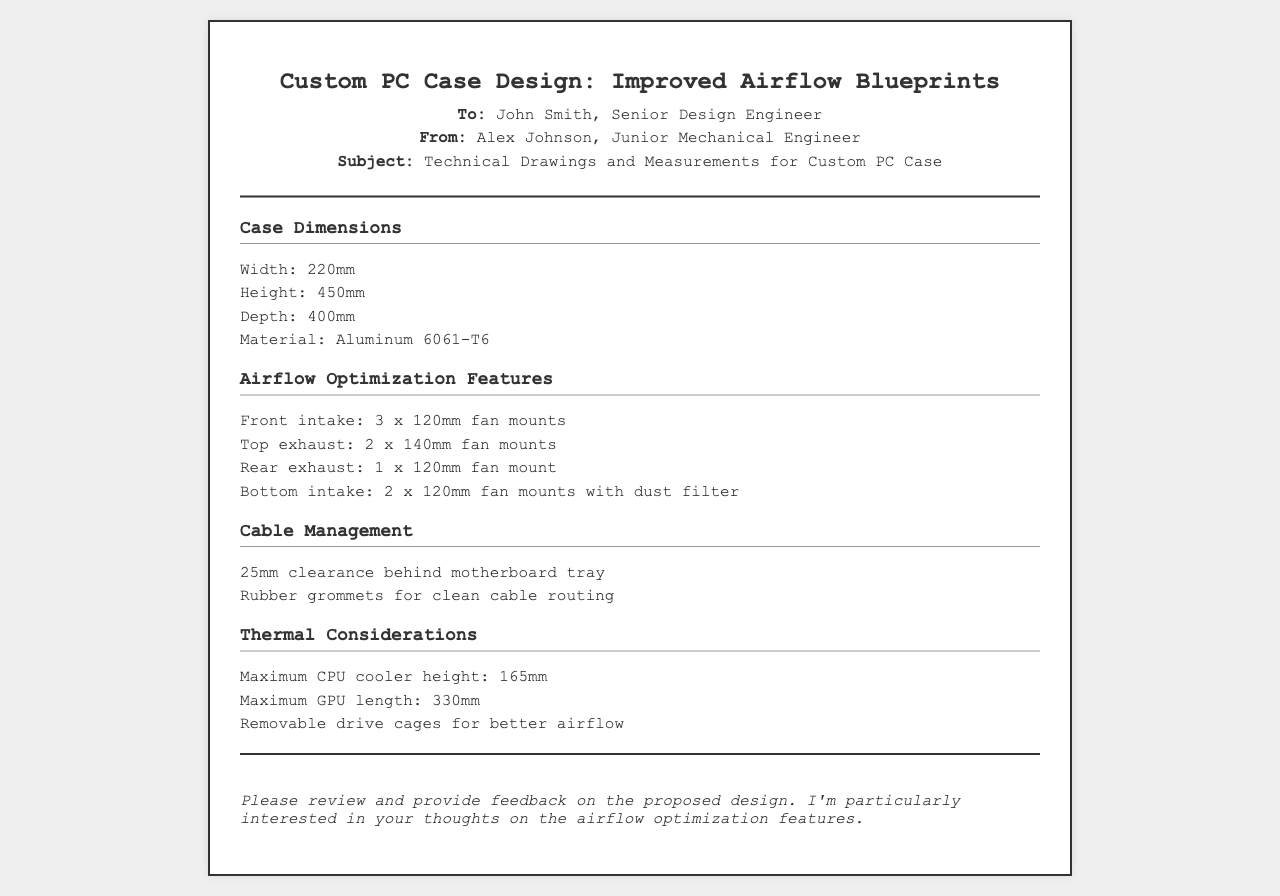What are the case dimensions? The case dimensions are detailed in the document, specifying width, height, and depth, which are 220mm, 450mm, and 400mm respectively.
Answer: 220mm, 450mm, 400mm What material is used in the case? The document specifies the material used for the custom PC case as Aluminum 6061-T6.
Answer: Aluminum 6061-T6 How many fan mounts are available for front intake? The document states there are 3 fan mounts available for front intake.
Answer: 3 x 120mm What is the maximum CPU cooler height? The maximum CPU cooler height mentioned in the document is critical for thermal considerations and is specified as 165mm.
Answer: 165mm How many rubber grommets are mentioned for cable management? The document highlights the use of rubber grommets for clean cable routing but does not specify a quantity.
Answer: Not specified What feature helps in dust prevention? The document mentions a dust filter with the bottom intake fan mounts that aids in dust prevention.
Answer: Dust filter What is the maximum GPU length? The document states the maximum GPU length that fits within the case is 330mm.
Answer: 330mm What is the clearance behind the motherboard tray? The clearance measurement provided in the document for behind the motherboard tray is 25mm.
Answer: 25mm What feedback is requested from John Smith? The author is particularly interested in feedback regarding the airflow optimization features of the design.
Answer: Airflow optimization features 